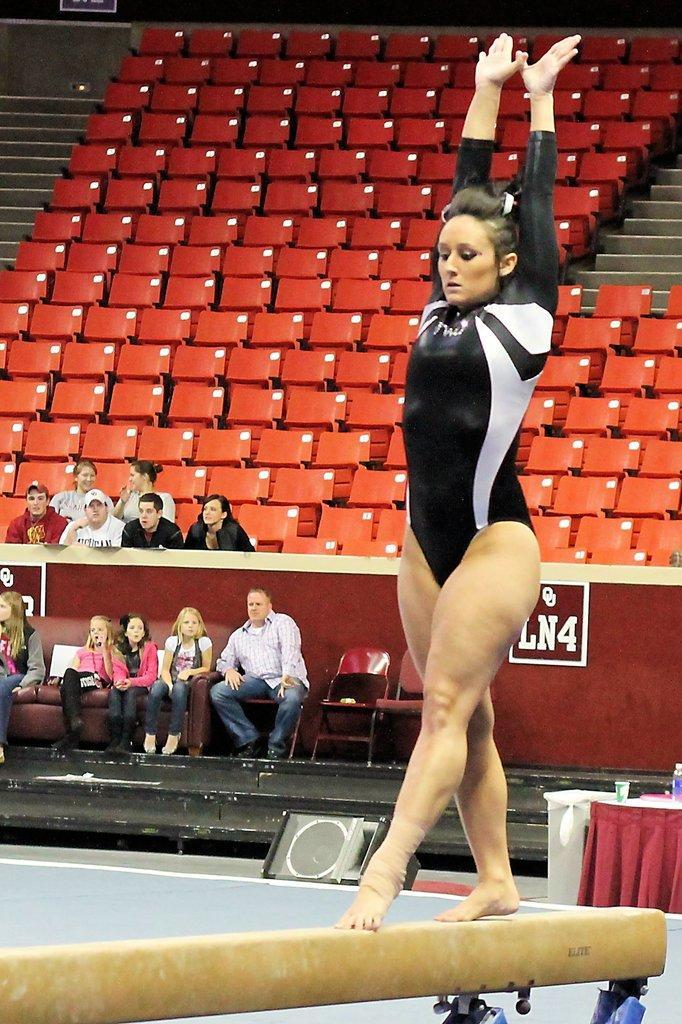In one or two sentences, can you explain what this image depicts? In this image a woman is walking on the rod. Right side there is a table having a glass and bottle on it. Few persons are sitting on the chairs. Few persons are behind the fence. There are few chairs on the stairs. 